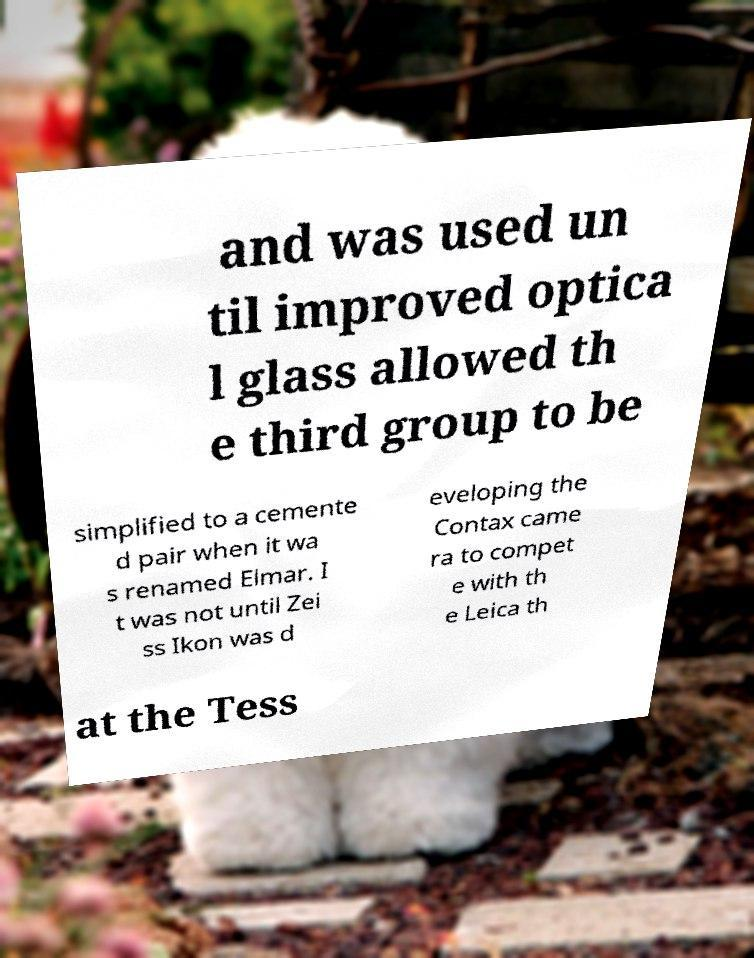There's text embedded in this image that I need extracted. Can you transcribe it verbatim? and was used un til improved optica l glass allowed th e third group to be simplified to a cemente d pair when it wa s renamed Elmar. I t was not until Zei ss Ikon was d eveloping the Contax came ra to compet e with th e Leica th at the Tess 